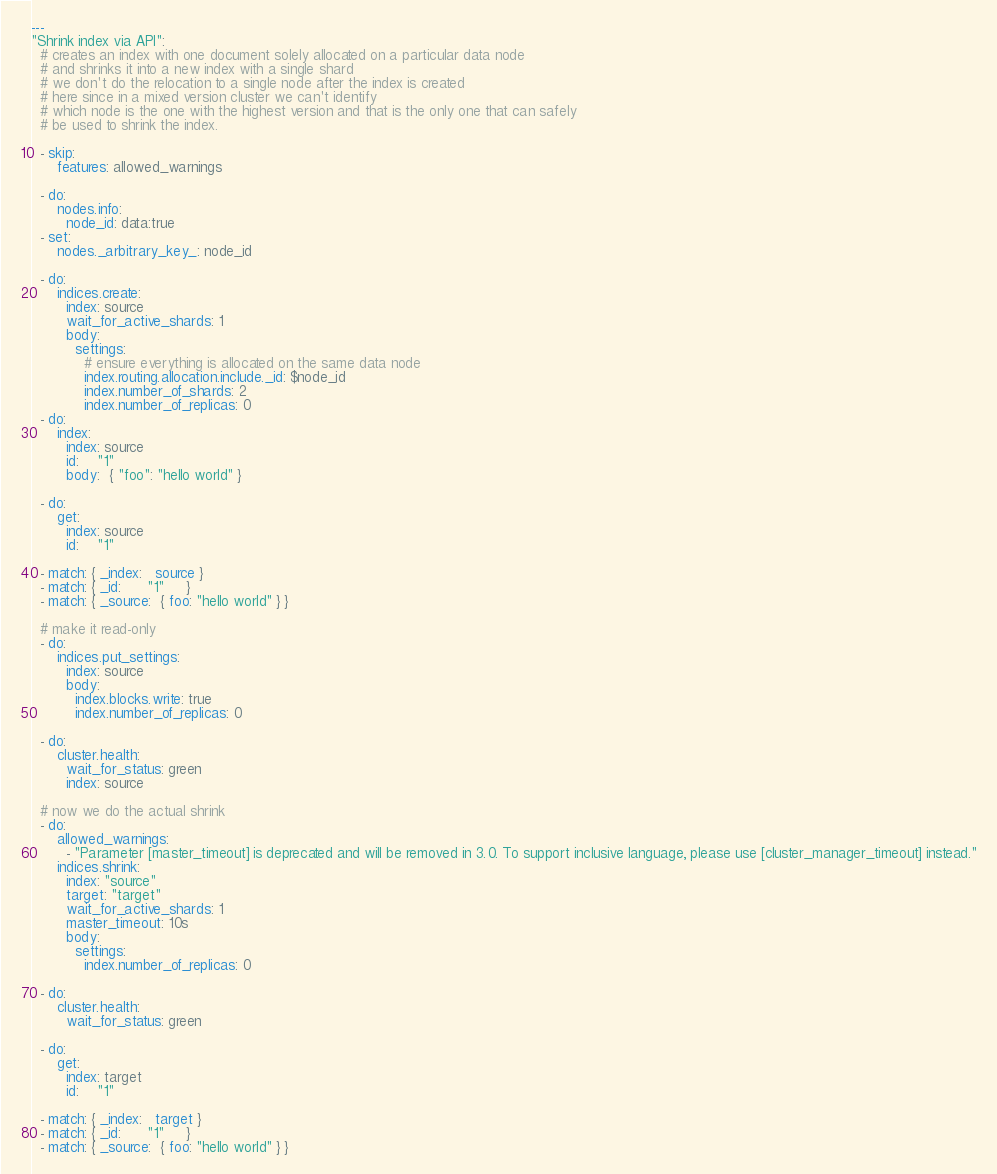<code> <loc_0><loc_0><loc_500><loc_500><_YAML_>---
"Shrink index via API":
  # creates an index with one document solely allocated on a particular data node
  # and shrinks it into a new index with a single shard
  # we don't do the relocation to a single node after the index is created
  # here since in a mixed version cluster we can't identify
  # which node is the one with the highest version and that is the only one that can safely
  # be used to shrink the index.

  - skip:
      features: allowed_warnings

  - do:
      nodes.info:
        node_id: data:true
  - set:
      nodes._arbitrary_key_: node_id

  - do:
      indices.create:
        index: source
        wait_for_active_shards: 1
        body:
          settings:
            # ensure everything is allocated on the same data node
            index.routing.allocation.include._id: $node_id
            index.number_of_shards: 2
            index.number_of_replicas: 0
  - do:
      index:
        index: source
        id:    "1"
        body:  { "foo": "hello world" }

  - do:
      get:
        index: source
        id:    "1"

  - match: { _index:   source }
  - match: { _id:      "1"     }
  - match: { _source:  { foo: "hello world" } }

  # make it read-only
  - do:
      indices.put_settings:
        index: source
        body:
          index.blocks.write: true
          index.number_of_replicas: 0

  - do:
      cluster.health:
        wait_for_status: green
        index: source

  # now we do the actual shrink
  - do:
      allowed_warnings:
        - "Parameter [master_timeout] is deprecated and will be removed in 3.0. To support inclusive language, please use [cluster_manager_timeout] instead."
      indices.shrink:
        index: "source"
        target: "target"
        wait_for_active_shards: 1
        master_timeout: 10s
        body:
          settings:
            index.number_of_replicas: 0

  - do:
      cluster.health:
        wait_for_status: green

  - do:
      get:
        index: target
        id:    "1"

  - match: { _index:   target }
  - match: { _id:      "1"     }
  - match: { _source:  { foo: "hello world" } }
</code> 